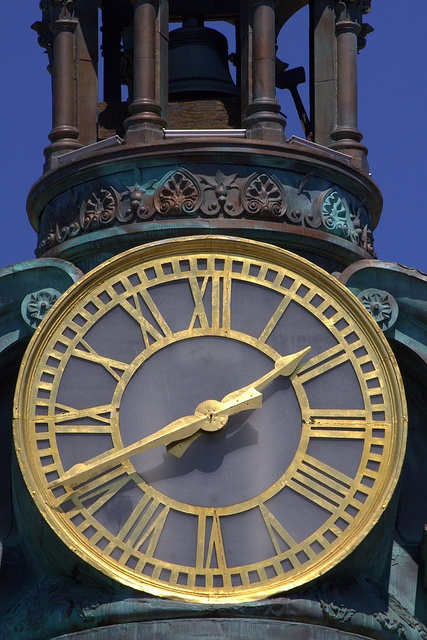Describe the objects in this image and their specific colors. I can see a clock in blue, gray, and tan tones in this image. 